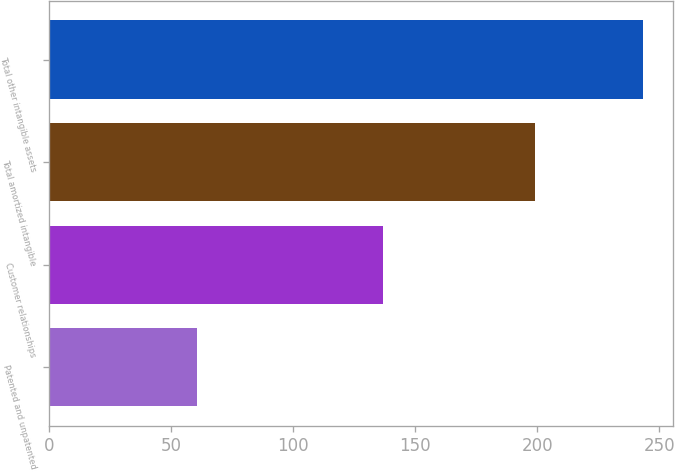Convert chart. <chart><loc_0><loc_0><loc_500><loc_500><bar_chart><fcel>Patented and unpatented<fcel>Customer relationships<fcel>Total amortized intangible<fcel>Total other intangible assets<nl><fcel>60.8<fcel>136.7<fcel>199<fcel>243.3<nl></chart> 